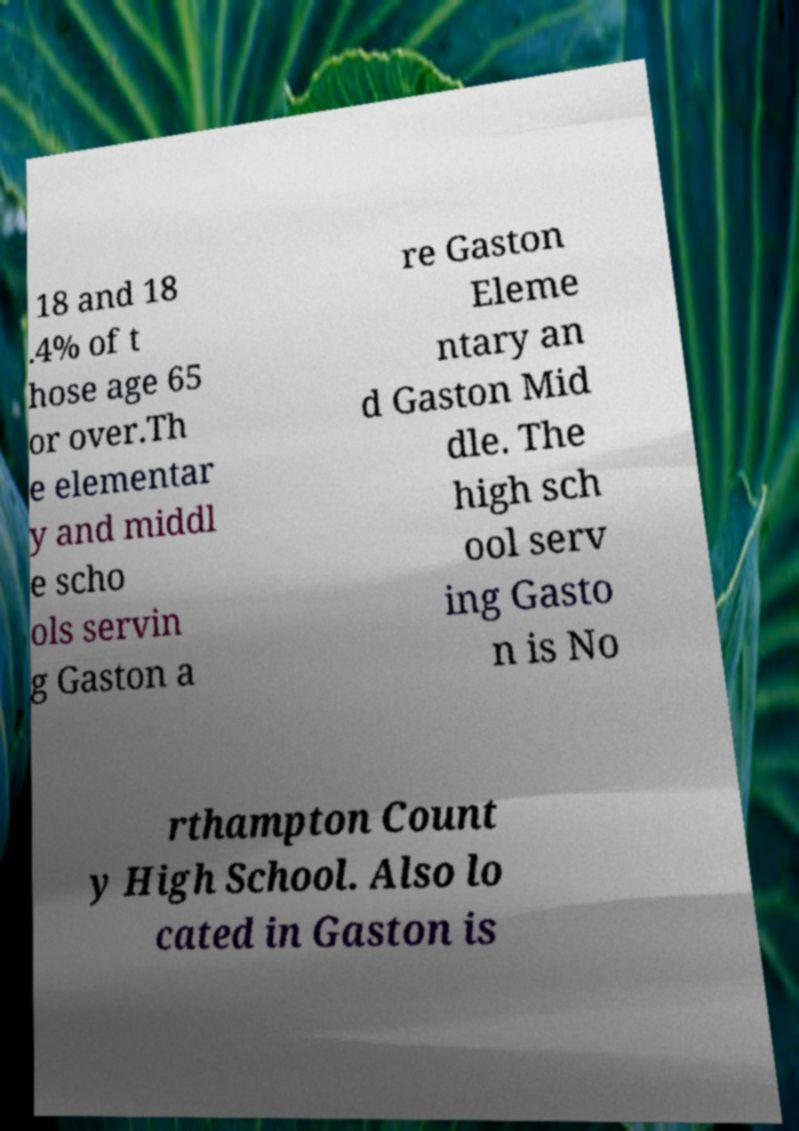I need the written content from this picture converted into text. Can you do that? 18 and 18 .4% of t hose age 65 or over.Th e elementar y and middl e scho ols servin g Gaston a re Gaston Eleme ntary an d Gaston Mid dle. The high sch ool serv ing Gasto n is No rthampton Count y High School. Also lo cated in Gaston is 